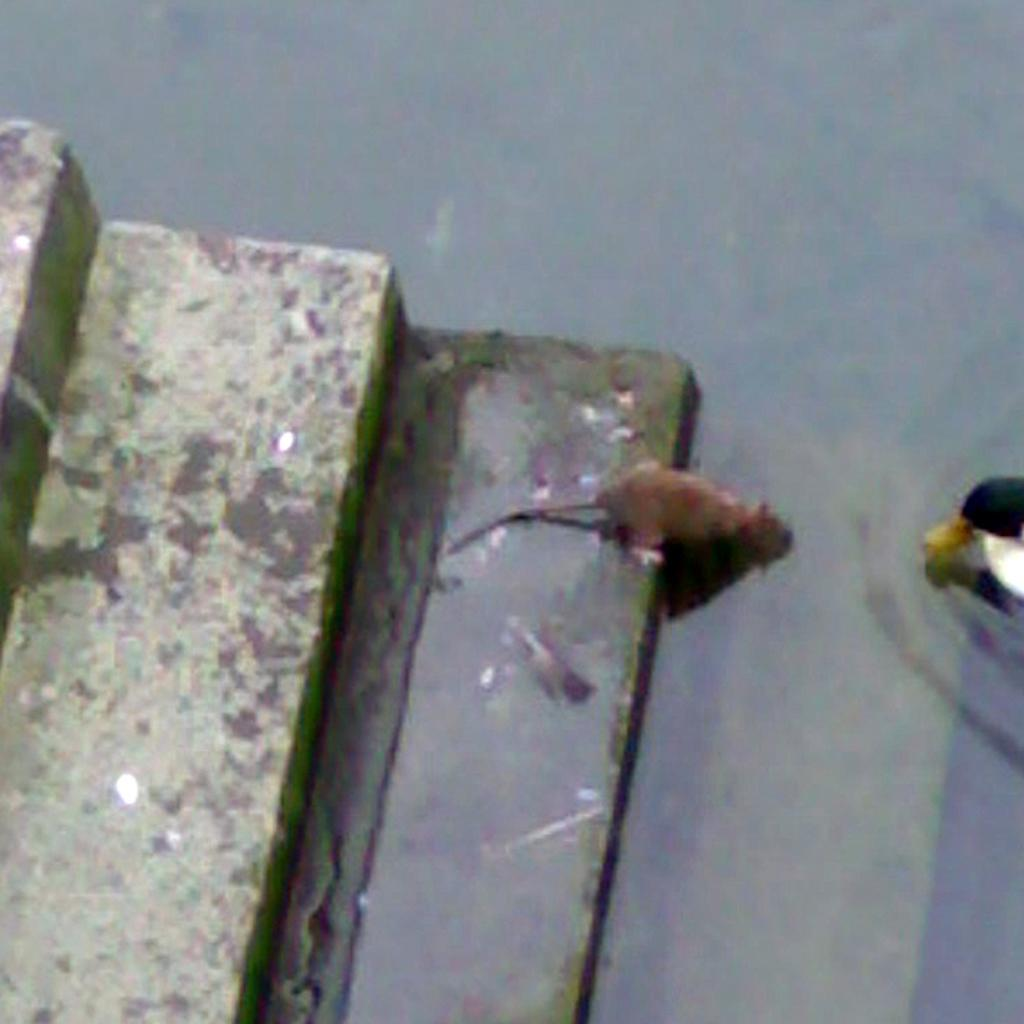What type of animal can be seen in the image? There is a rat in the image. What else is present in the image besides the rat? There is an object and stairs visible in the image. Is there any liquid visible in the image? Yes, there is water visible in the image. How many pizzas are being carried by the cattle in the image? There are no cattle or pizzas present in the image. 